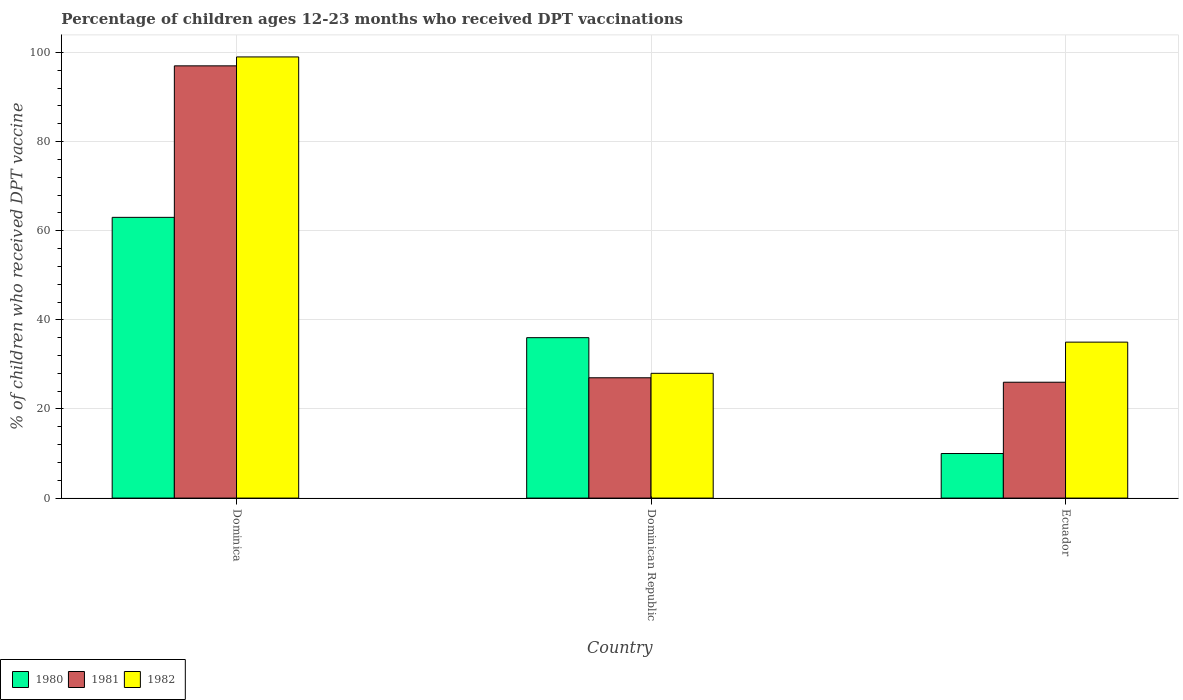How many groups of bars are there?
Offer a terse response. 3. Are the number of bars per tick equal to the number of legend labels?
Your response must be concise. Yes. How many bars are there on the 2nd tick from the right?
Keep it short and to the point. 3. What is the label of the 2nd group of bars from the left?
Your answer should be very brief. Dominican Republic. What is the percentage of children who received DPT vaccination in 1982 in Ecuador?
Your answer should be compact. 35. Across all countries, what is the maximum percentage of children who received DPT vaccination in 1981?
Provide a succinct answer. 97. Across all countries, what is the minimum percentage of children who received DPT vaccination in 1982?
Make the answer very short. 28. In which country was the percentage of children who received DPT vaccination in 1982 maximum?
Keep it short and to the point. Dominica. In which country was the percentage of children who received DPT vaccination in 1981 minimum?
Ensure brevity in your answer.  Ecuador. What is the total percentage of children who received DPT vaccination in 1981 in the graph?
Offer a terse response. 150. What is the average percentage of children who received DPT vaccination in 1980 per country?
Your answer should be very brief. 36.33. What is the difference between the percentage of children who received DPT vaccination of/in 1982 and percentage of children who received DPT vaccination of/in 1980 in Dominican Republic?
Ensure brevity in your answer.  -8. What is the ratio of the percentage of children who received DPT vaccination in 1980 in Dominica to that in Dominican Republic?
Offer a very short reply. 1.75. Is the difference between the percentage of children who received DPT vaccination in 1982 in Dominican Republic and Ecuador greater than the difference between the percentage of children who received DPT vaccination in 1980 in Dominican Republic and Ecuador?
Your answer should be compact. No. What is the difference between the highest and the second highest percentage of children who received DPT vaccination in 1982?
Your answer should be very brief. -64. What is the difference between the highest and the lowest percentage of children who received DPT vaccination in 1980?
Keep it short and to the point. 53. In how many countries, is the percentage of children who received DPT vaccination in 1980 greater than the average percentage of children who received DPT vaccination in 1980 taken over all countries?
Offer a very short reply. 1. Is the sum of the percentage of children who received DPT vaccination in 1980 in Dominican Republic and Ecuador greater than the maximum percentage of children who received DPT vaccination in 1981 across all countries?
Your response must be concise. No. Is it the case that in every country, the sum of the percentage of children who received DPT vaccination in 1980 and percentage of children who received DPT vaccination in 1982 is greater than the percentage of children who received DPT vaccination in 1981?
Provide a succinct answer. Yes. How many bars are there?
Provide a short and direct response. 9. Are all the bars in the graph horizontal?
Your answer should be compact. No. Does the graph contain grids?
Offer a terse response. Yes. Where does the legend appear in the graph?
Your answer should be compact. Bottom left. How are the legend labels stacked?
Provide a short and direct response. Horizontal. What is the title of the graph?
Keep it short and to the point. Percentage of children ages 12-23 months who received DPT vaccinations. What is the label or title of the Y-axis?
Provide a short and direct response. % of children who received DPT vaccine. What is the % of children who received DPT vaccine in 1980 in Dominica?
Give a very brief answer. 63. What is the % of children who received DPT vaccine of 1981 in Dominica?
Give a very brief answer. 97. What is the % of children who received DPT vaccine in 1982 in Dominica?
Offer a terse response. 99. What is the % of children who received DPT vaccine in 1981 in Dominican Republic?
Make the answer very short. 27. What is the % of children who received DPT vaccine in 1982 in Dominican Republic?
Your response must be concise. 28. What is the % of children who received DPT vaccine of 1980 in Ecuador?
Give a very brief answer. 10. What is the % of children who received DPT vaccine of 1982 in Ecuador?
Provide a short and direct response. 35. Across all countries, what is the maximum % of children who received DPT vaccine of 1980?
Offer a terse response. 63. Across all countries, what is the maximum % of children who received DPT vaccine of 1981?
Provide a succinct answer. 97. Across all countries, what is the minimum % of children who received DPT vaccine of 1981?
Keep it short and to the point. 26. What is the total % of children who received DPT vaccine in 1980 in the graph?
Ensure brevity in your answer.  109. What is the total % of children who received DPT vaccine in 1981 in the graph?
Give a very brief answer. 150. What is the total % of children who received DPT vaccine of 1982 in the graph?
Offer a very short reply. 162. What is the difference between the % of children who received DPT vaccine in 1980 in Dominica and that in Dominican Republic?
Offer a very short reply. 27. What is the difference between the % of children who received DPT vaccine in 1981 in Dominica and that in Dominican Republic?
Your response must be concise. 70. What is the difference between the % of children who received DPT vaccine of 1982 in Dominica and that in Dominican Republic?
Give a very brief answer. 71. What is the difference between the % of children who received DPT vaccine in 1982 in Dominica and that in Ecuador?
Ensure brevity in your answer.  64. What is the difference between the % of children who received DPT vaccine of 1980 in Dominican Republic and that in Ecuador?
Your answer should be compact. 26. What is the difference between the % of children who received DPT vaccine in 1981 in Dominican Republic and that in Ecuador?
Make the answer very short. 1. What is the difference between the % of children who received DPT vaccine of 1982 in Dominican Republic and that in Ecuador?
Provide a succinct answer. -7. What is the difference between the % of children who received DPT vaccine in 1980 in Dominica and the % of children who received DPT vaccine in 1982 in Dominican Republic?
Provide a succinct answer. 35. What is the difference between the % of children who received DPT vaccine in 1980 in Dominica and the % of children who received DPT vaccine in 1981 in Ecuador?
Offer a very short reply. 37. What is the difference between the % of children who received DPT vaccine in 1981 in Dominica and the % of children who received DPT vaccine in 1982 in Ecuador?
Provide a short and direct response. 62. What is the average % of children who received DPT vaccine of 1980 per country?
Offer a terse response. 36.33. What is the average % of children who received DPT vaccine in 1981 per country?
Your answer should be compact. 50. What is the difference between the % of children who received DPT vaccine in 1980 and % of children who received DPT vaccine in 1981 in Dominica?
Offer a very short reply. -34. What is the difference between the % of children who received DPT vaccine in 1980 and % of children who received DPT vaccine in 1982 in Dominica?
Ensure brevity in your answer.  -36. What is the difference between the % of children who received DPT vaccine of 1981 and % of children who received DPT vaccine of 1982 in Ecuador?
Provide a short and direct response. -9. What is the ratio of the % of children who received DPT vaccine of 1981 in Dominica to that in Dominican Republic?
Provide a succinct answer. 3.59. What is the ratio of the % of children who received DPT vaccine of 1982 in Dominica to that in Dominican Republic?
Offer a terse response. 3.54. What is the ratio of the % of children who received DPT vaccine of 1981 in Dominica to that in Ecuador?
Your answer should be very brief. 3.73. What is the ratio of the % of children who received DPT vaccine in 1982 in Dominica to that in Ecuador?
Give a very brief answer. 2.83. What is the ratio of the % of children who received DPT vaccine of 1980 in Dominican Republic to that in Ecuador?
Your answer should be compact. 3.6. What is the ratio of the % of children who received DPT vaccine of 1981 in Dominican Republic to that in Ecuador?
Offer a terse response. 1.04. What is the difference between the highest and the second highest % of children who received DPT vaccine in 1980?
Provide a short and direct response. 27. What is the difference between the highest and the second highest % of children who received DPT vaccine of 1982?
Ensure brevity in your answer.  64. What is the difference between the highest and the lowest % of children who received DPT vaccine of 1980?
Offer a terse response. 53. 